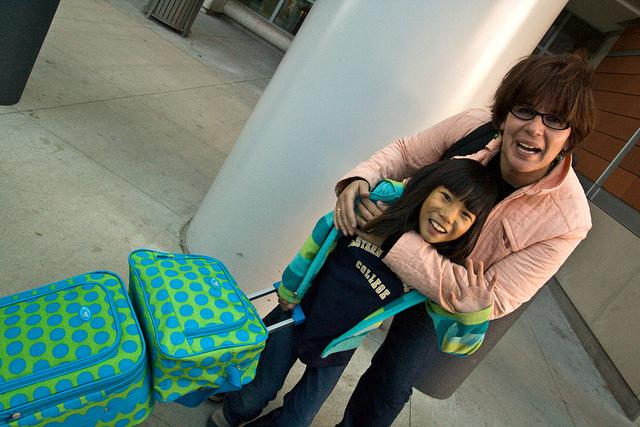Why is the young girl holding luggage?

Choices:
A) to sell
B) to travel
C) to pack
D) to purchase to travel 